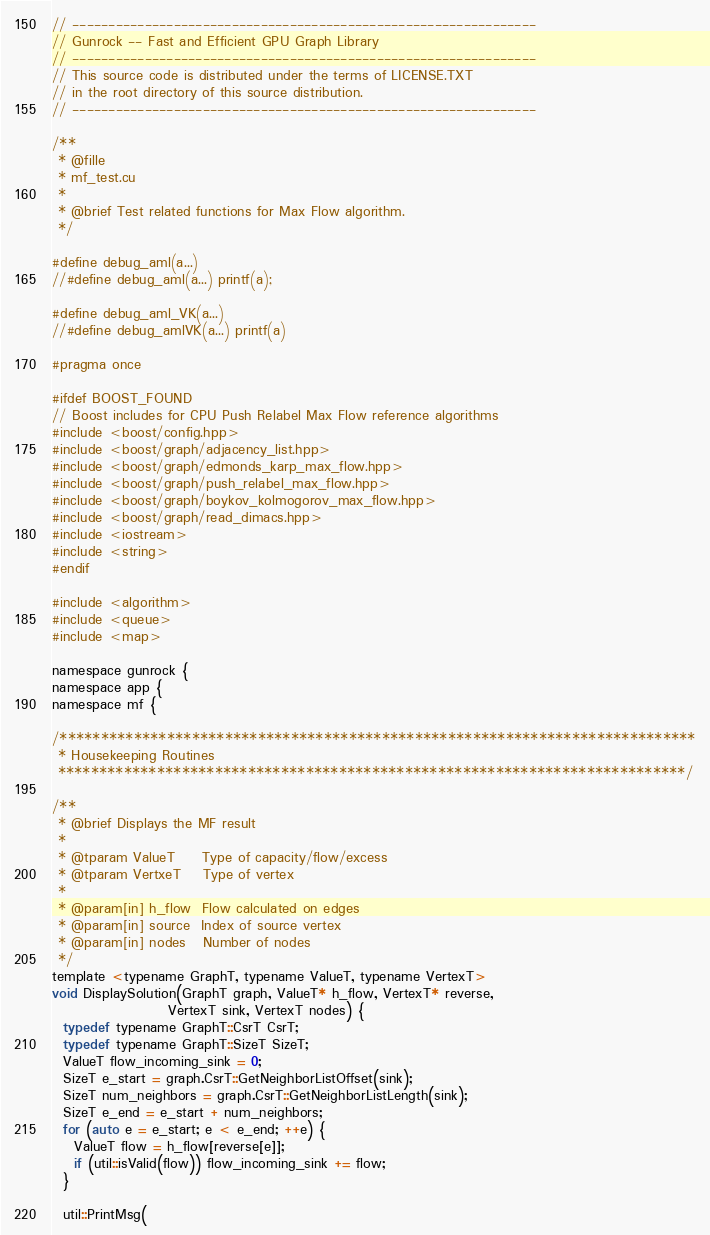<code> <loc_0><loc_0><loc_500><loc_500><_Cuda_>// ----------------------------------------------------------------
// Gunrock -- Fast and Efficient GPU Graph Library
// ----------------------------------------------------------------
// This source code is distributed under the terms of LICENSE.TXT
// in the root directory of this source distribution.
// ----------------------------------------------------------------

/**
 * @fille
 * mf_test.cu
 *
 * @brief Test related functions for Max Flow algorithm.
 */

#define debug_aml(a...)
//#define debug_aml(a...) printf(a);

#define debug_aml_VK(a...)
//#define debug_amlVK(a...) printf(a)

#pragma once

#ifdef BOOST_FOUND
// Boost includes for CPU Push Relabel Max Flow reference algorithms
#include <boost/config.hpp>
#include <boost/graph/adjacency_list.hpp>
#include <boost/graph/edmonds_karp_max_flow.hpp>
#include <boost/graph/push_relabel_max_flow.hpp>
#include <boost/graph/boykov_kolmogorov_max_flow.hpp>
#include <boost/graph/read_dimacs.hpp>
#include <iostream>
#include <string>
#endif

#include <algorithm>
#include <queue>
#include <map>

namespace gunrock {
namespace app {
namespace mf {

/*****************************************************************************
 * Housekeeping Routines
 ****************************************************************************/

/**
 * @brief Displays the MF result
 *
 * @tparam ValueT     Type of capacity/flow/excess
 * @tparam VertxeT    Type of vertex
 *
 * @param[in] h_flow  Flow calculated on edges
 * @param[in] source  Index of source vertex
 * @param[in] nodes   Number of nodes
 */
template <typename GraphT, typename ValueT, typename VertexT>
void DisplaySolution(GraphT graph, ValueT* h_flow, VertexT* reverse,
                     VertexT sink, VertexT nodes) {
  typedef typename GraphT::CsrT CsrT;
  typedef typename GraphT::SizeT SizeT;
  ValueT flow_incoming_sink = 0;
  SizeT e_start = graph.CsrT::GetNeighborListOffset(sink);
  SizeT num_neighbors = graph.CsrT::GetNeighborListLength(sink);
  SizeT e_end = e_start + num_neighbors;
  for (auto e = e_start; e < e_end; ++e) {
    ValueT flow = h_flow[reverse[e]];
    if (util::isValid(flow)) flow_incoming_sink += flow;
  }

  util::PrintMsg(</code> 